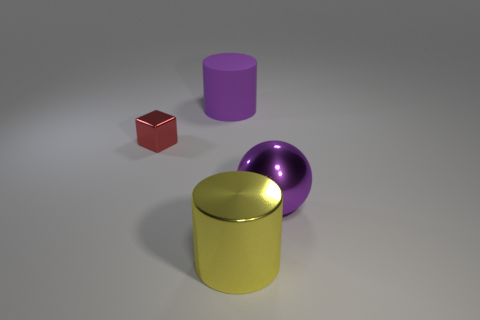The purple thing that is the same material as the yellow cylinder is what size?
Offer a terse response. Large. How many objects are metallic things to the right of the large shiny cylinder or metal cylinders?
Give a very brief answer. 2. There is a big cylinder right of the purple cylinder; does it have the same color as the big rubber cylinder?
Ensure brevity in your answer.  No. There is a metallic object that is the same shape as the big rubber thing; what size is it?
Offer a terse response. Large. The big metallic object in front of the big purple thing in front of the cylinder behind the red block is what color?
Give a very brief answer. Yellow. Is the material of the large yellow cylinder the same as the sphere?
Give a very brief answer. Yes. There is a big purple object that is right of the large object behind the red block; is there a large purple metal object on the right side of it?
Keep it short and to the point. No. Does the ball have the same color as the shiny cylinder?
Offer a terse response. No. Is the number of tiny metallic objects less than the number of large shiny things?
Offer a very short reply. Yes. Do the cylinder that is in front of the sphere and the purple thing that is in front of the large purple cylinder have the same material?
Make the answer very short. Yes. 